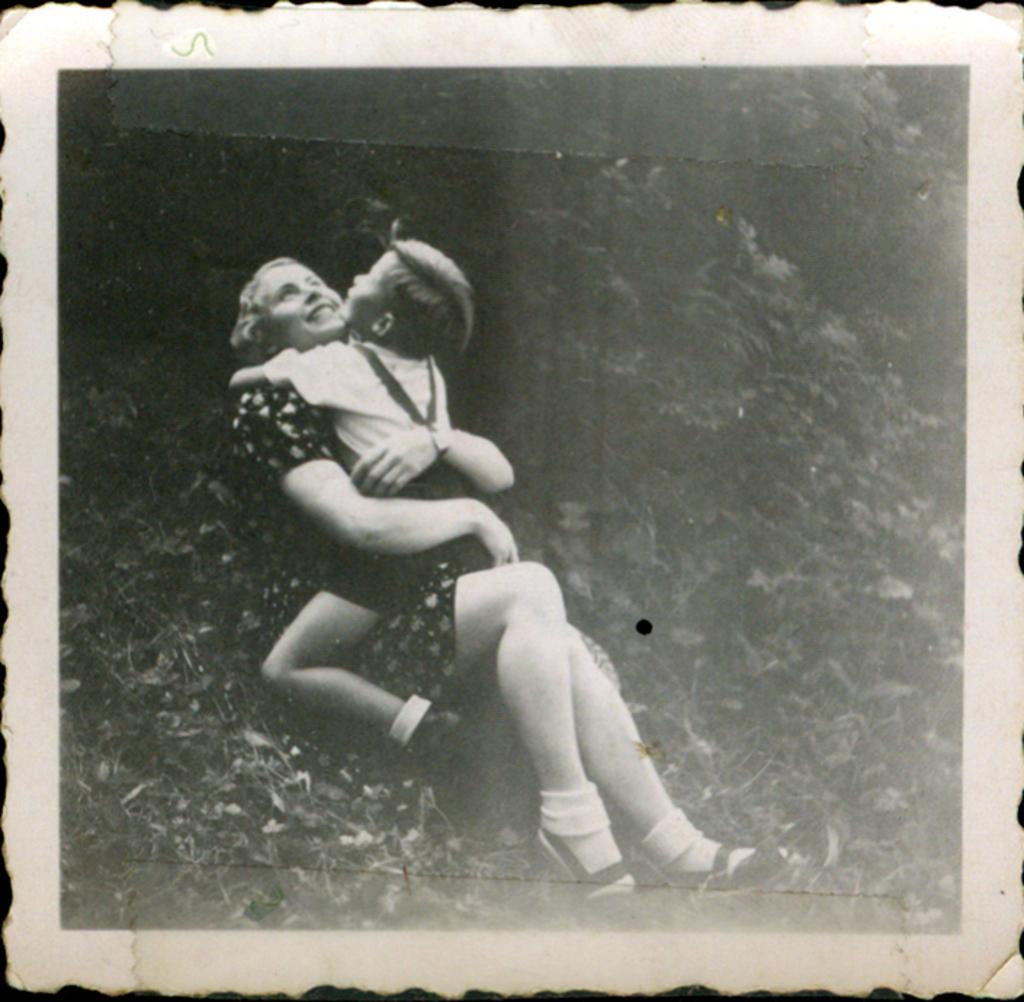What object is present in the image that holds a picture? There is a photo frame in the image. What can be seen in the photo frame? The photo frame contains a picture of a woman holding a boy. What is the emotional expression of the woman and the boy in the picture? The woman and the boy are smiling in the picture. What type of background is visible in the picture within the photo frame? Trees are visible in the picture within the photo frame. What type of ear is visible in the image? There is no ear visible in the image; the image contains a photo frame with a picture of a woman holding a boy. Can you tell me what the judge is wearing in the image? There is no judge present in the image; it contains a photo frame with a picture of a woman holding a boy. 